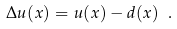Convert formula to latex. <formula><loc_0><loc_0><loc_500><loc_500>\Delta u ( x ) = u ( x ) - d ( x ) \ .</formula> 